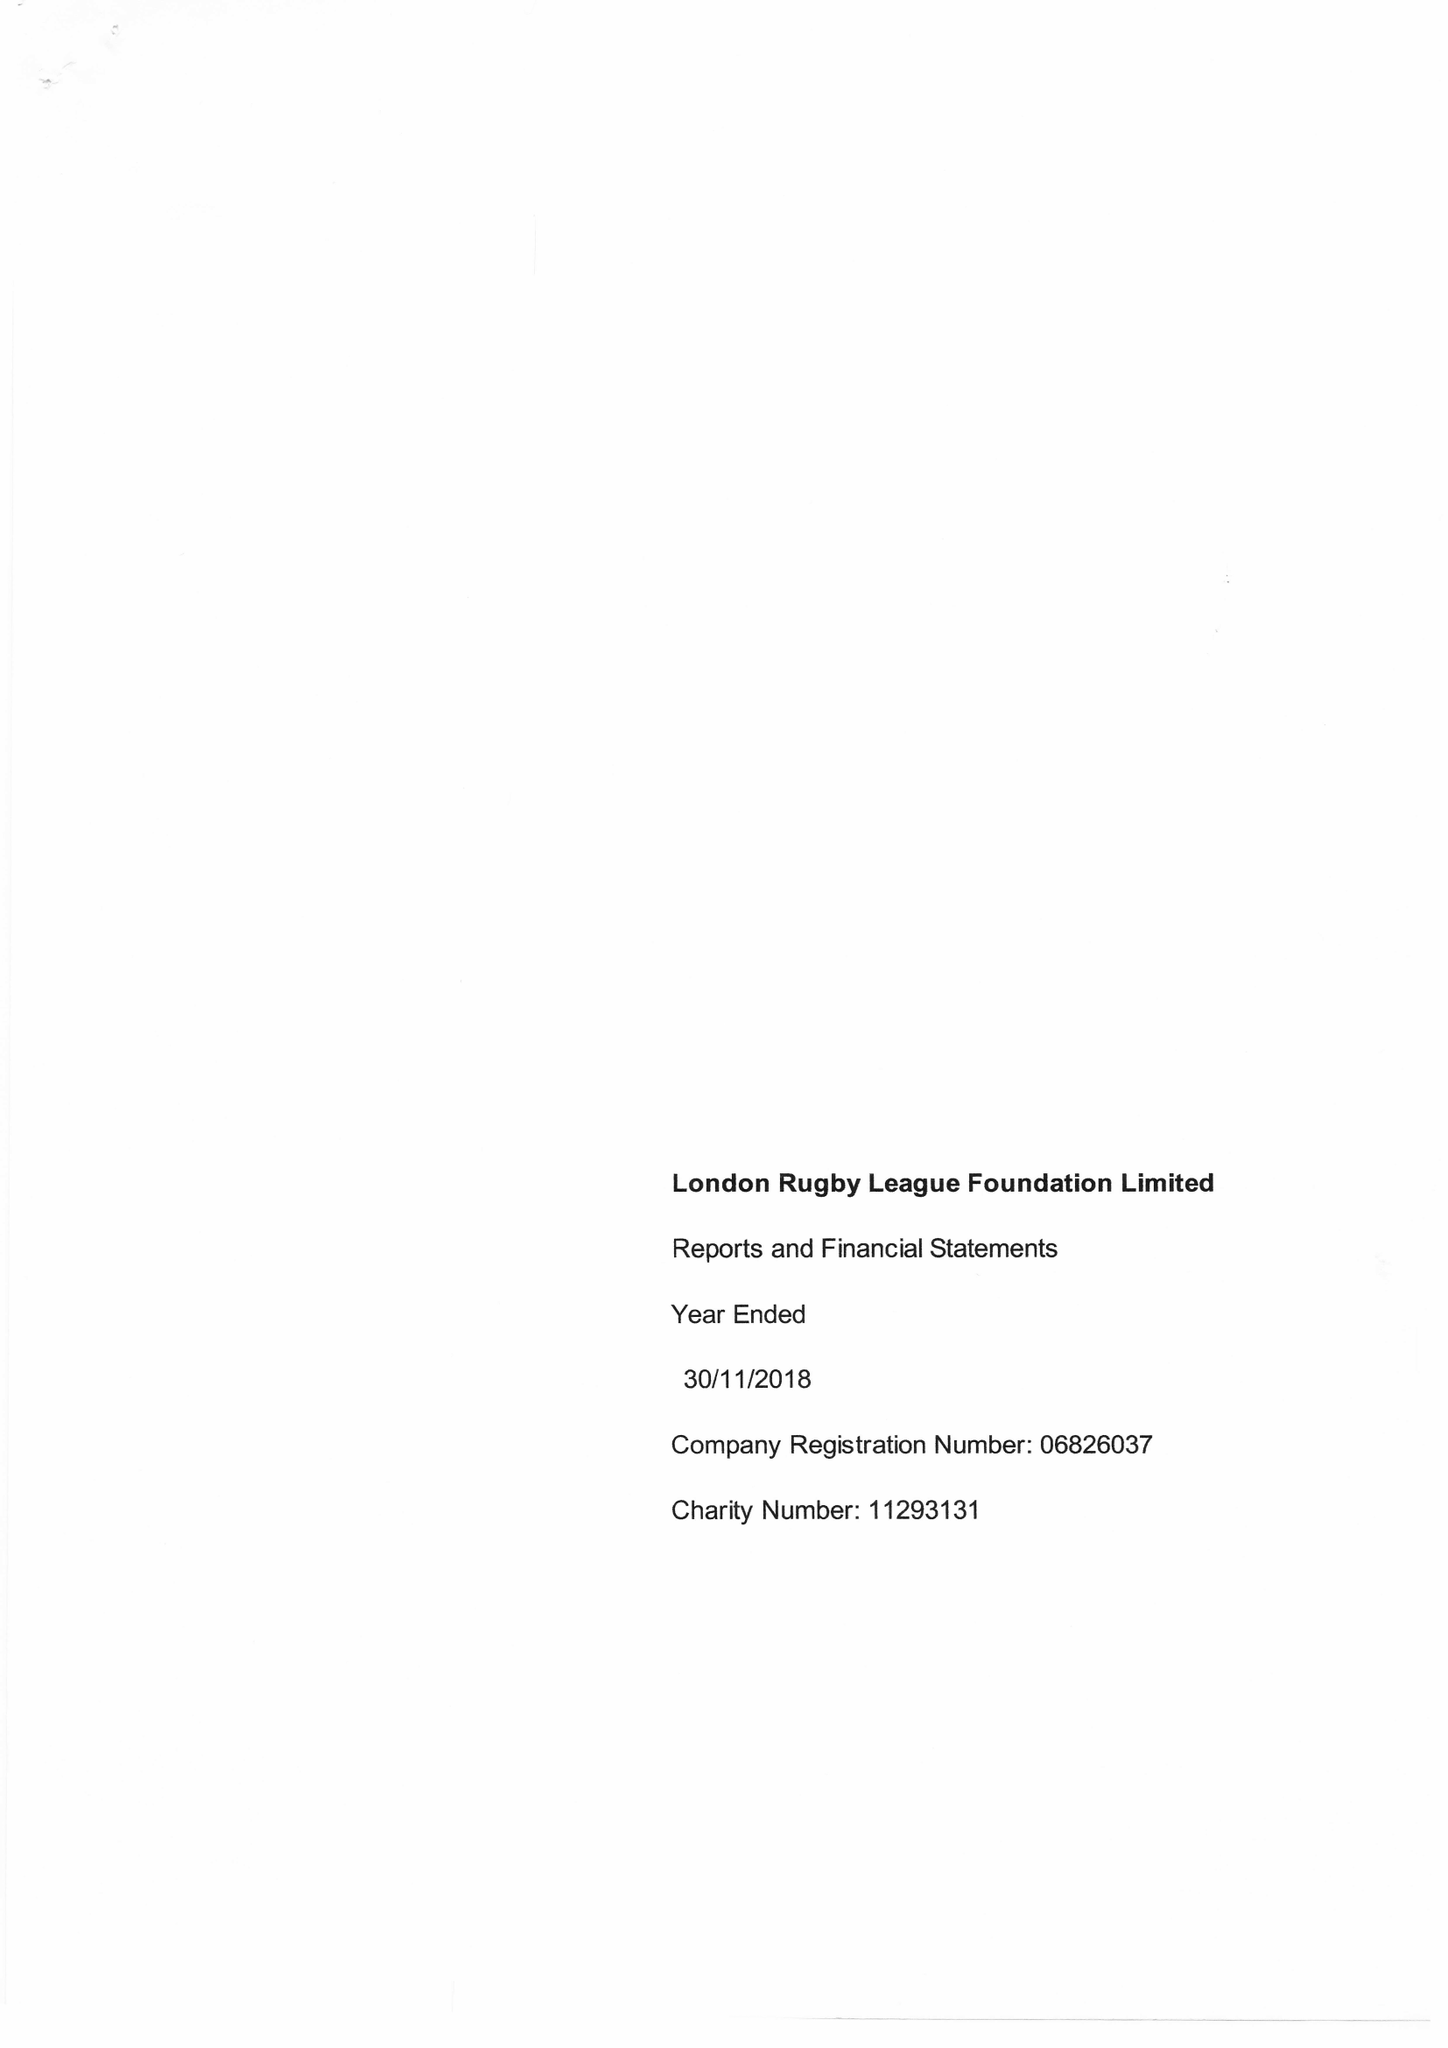What is the value for the spending_annually_in_british_pounds?
Answer the question using a single word or phrase. 198430.00 